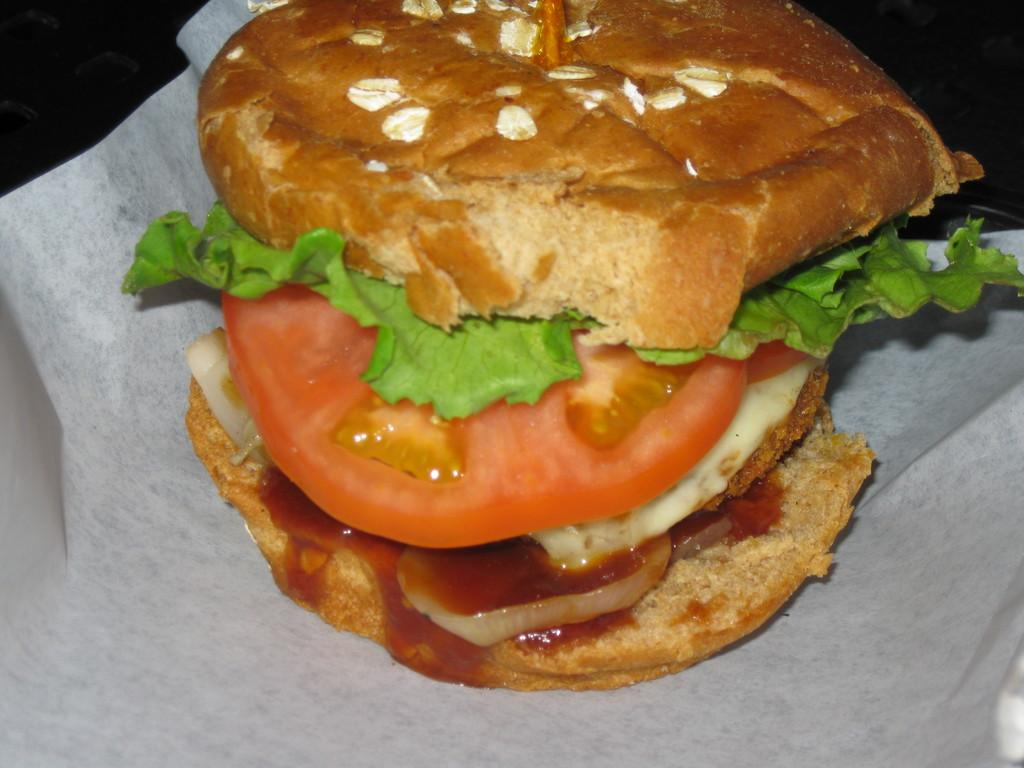What type of food is visible in the image? There is a burger in the image. What is the burger placed on? The burger is on a tissue. What color is the background of the image? The background of the image is black. What type of protest is happening in the image? There is no protest present in the image; it features a burger on a tissue with a black background. What type of mitten is visible in the image? There are no mittens present in the image. 